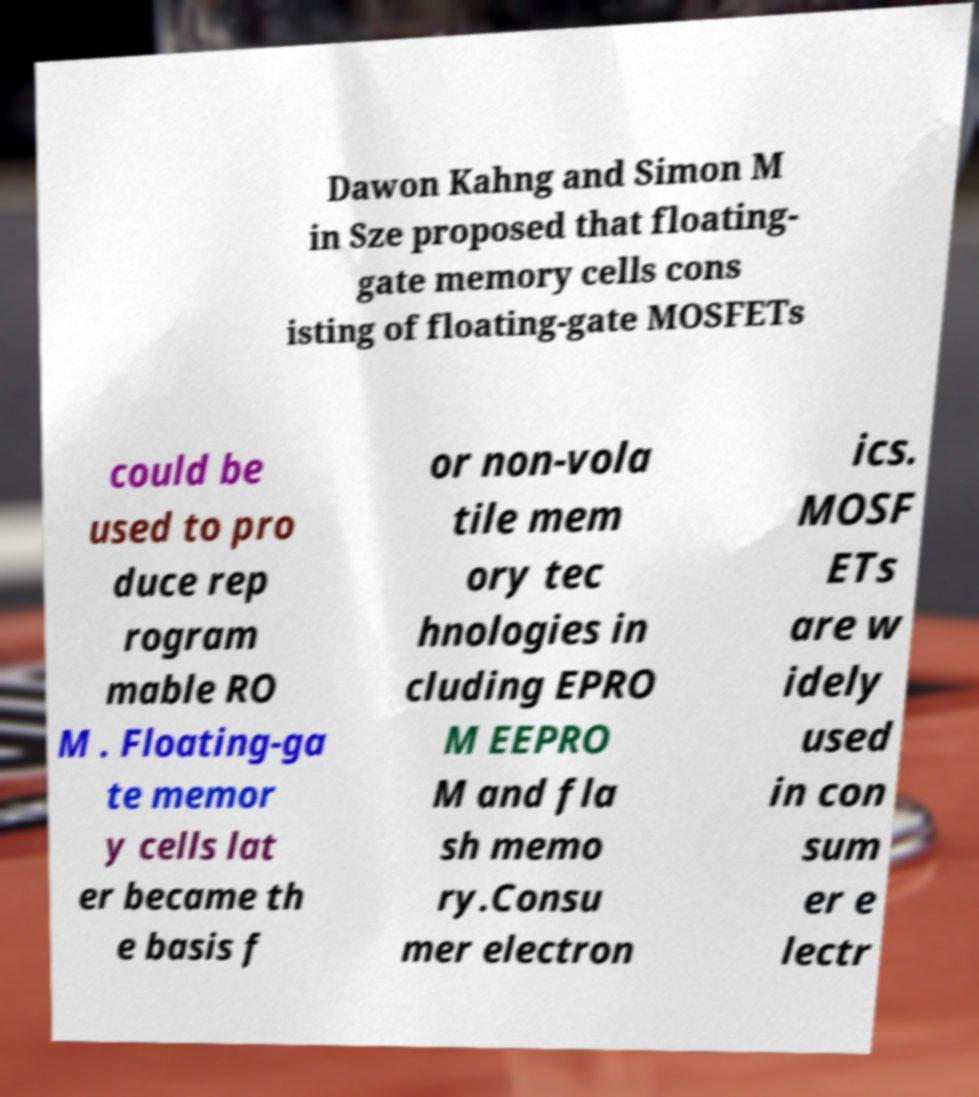Could you extract and type out the text from this image? Dawon Kahng and Simon M in Sze proposed that floating- gate memory cells cons isting of floating-gate MOSFETs could be used to pro duce rep rogram mable RO M . Floating-ga te memor y cells lat er became th e basis f or non-vola tile mem ory tec hnologies in cluding EPRO M EEPRO M and fla sh memo ry.Consu mer electron ics. MOSF ETs are w idely used in con sum er e lectr 